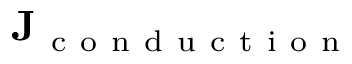<formula> <loc_0><loc_0><loc_500><loc_500>J _ { c o n d u c t i o n }</formula> 